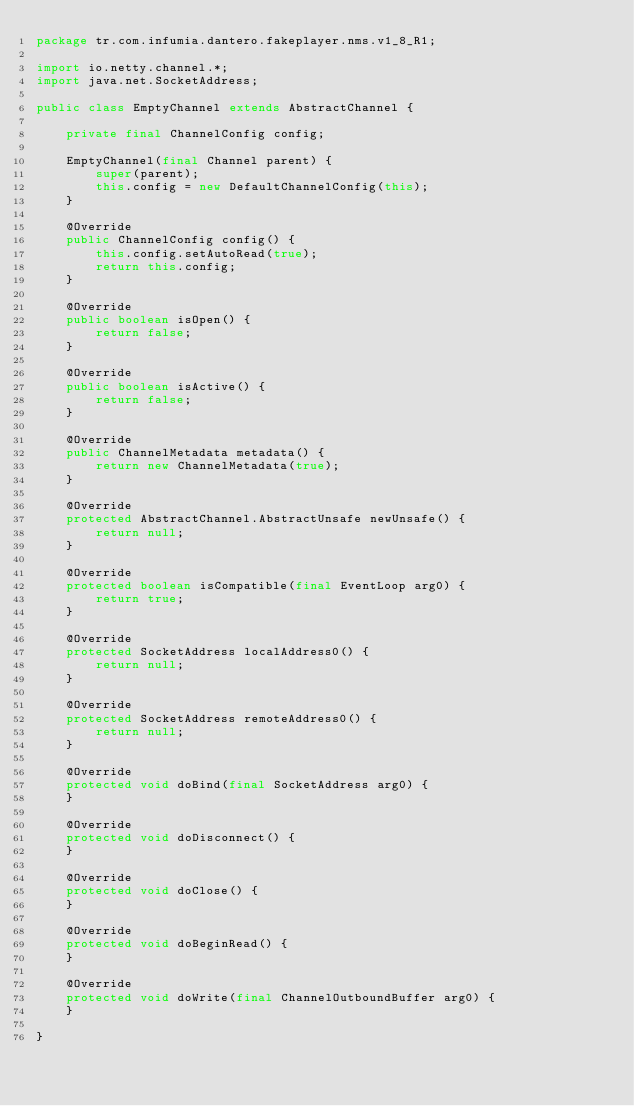Convert code to text. <code><loc_0><loc_0><loc_500><loc_500><_Java_>package tr.com.infumia.dantero.fakeplayer.nms.v1_8_R1;

import io.netty.channel.*;
import java.net.SocketAddress;

public class EmptyChannel extends AbstractChannel {

    private final ChannelConfig config;

    EmptyChannel(final Channel parent) {
        super(parent);
        this.config = new DefaultChannelConfig(this);
    }

    @Override
    public ChannelConfig config() {
        this.config.setAutoRead(true);
        return this.config;
    }

    @Override
    public boolean isOpen() {
        return false;
    }

    @Override
    public boolean isActive() {
        return false;
    }

    @Override
    public ChannelMetadata metadata() {
        return new ChannelMetadata(true);
    }

    @Override
    protected AbstractChannel.AbstractUnsafe newUnsafe() {
        return null;
    }

    @Override
    protected boolean isCompatible(final EventLoop arg0) {
        return true;
    }

    @Override
    protected SocketAddress localAddress0() {
        return null;
    }

    @Override
    protected SocketAddress remoteAddress0() {
        return null;
    }

    @Override
    protected void doBind(final SocketAddress arg0) {
    }

    @Override
    protected void doDisconnect() {
    }

    @Override
    protected void doClose() {
    }

    @Override
    protected void doBeginRead() {
    }

    @Override
    protected void doWrite(final ChannelOutboundBuffer arg0) {
    }

}</code> 